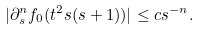<formula> <loc_0><loc_0><loc_500><loc_500>| \partial _ { s } ^ { n } f _ { 0 } ( t ^ { 2 } s ( s + 1 ) ) | \leq c s ^ { - n } .</formula> 